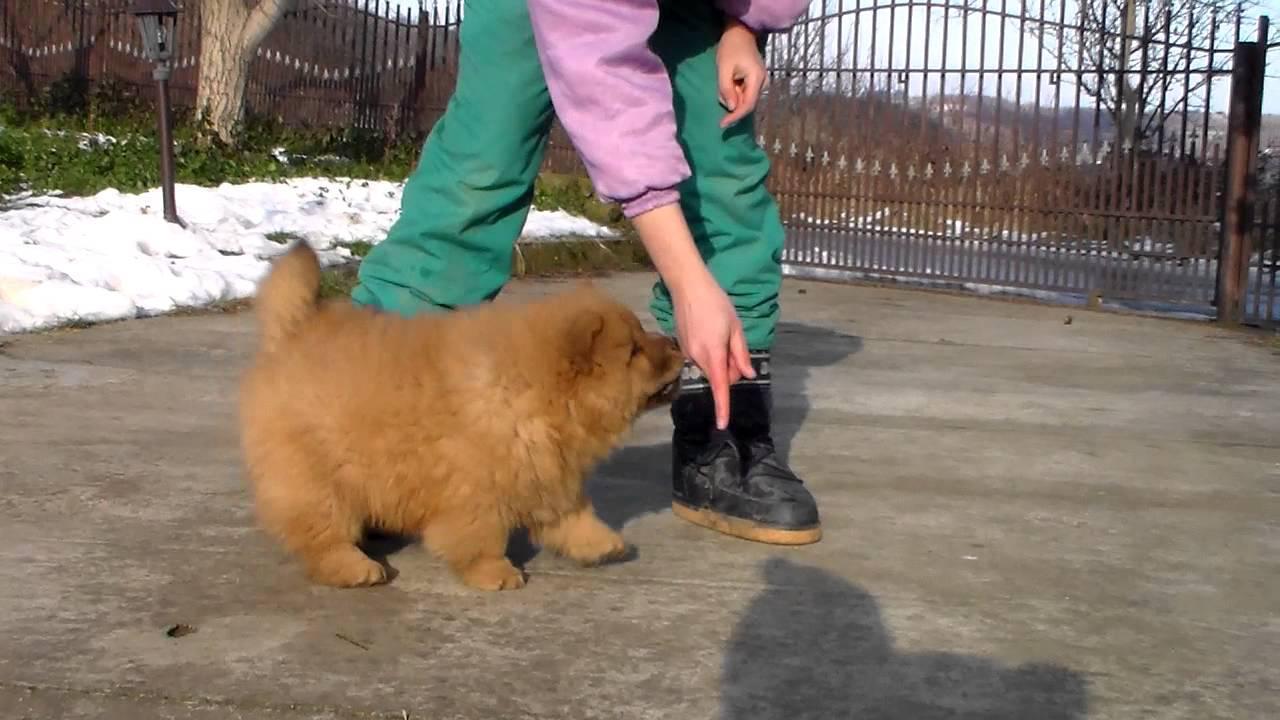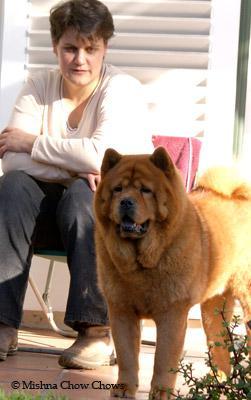The first image is the image on the left, the second image is the image on the right. Given the left and right images, does the statement "The dog in the image on the right is lying down." hold true? Answer yes or no. No. The first image is the image on the left, the second image is the image on the right. Considering the images on both sides, is "The left and right image contains the same number of dogs one dark brown and the other light brown." valid? Answer yes or no. No. 